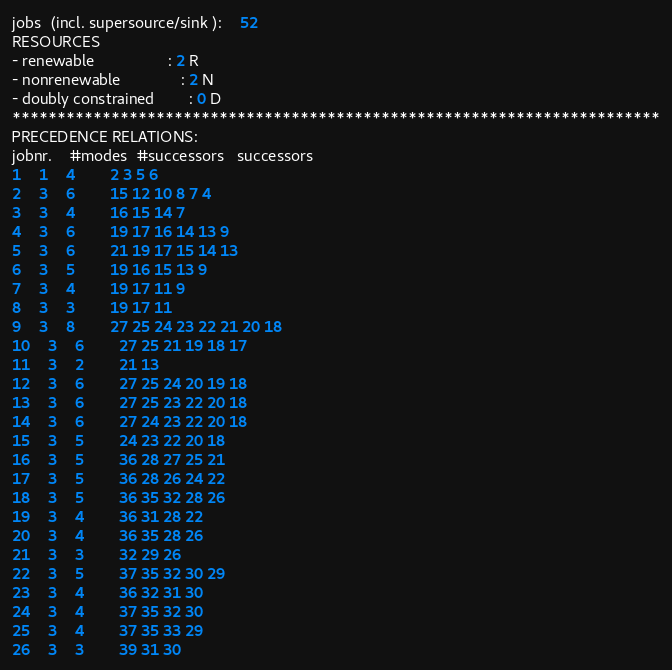Convert code to text. <code><loc_0><loc_0><loc_500><loc_500><_ObjectiveC_>jobs  (incl. supersource/sink ):	52
RESOURCES
- renewable                 : 2 R
- nonrenewable              : 2 N
- doubly constrained        : 0 D
************************************************************************
PRECEDENCE RELATIONS:
jobnr.    #modes  #successors   successors
1	1	4		2 3 5 6 
2	3	6		15 12 10 8 7 4 
3	3	4		16 15 14 7 
4	3	6		19 17 16 14 13 9 
5	3	6		21 19 17 15 14 13 
6	3	5		19 16 15 13 9 
7	3	4		19 17 11 9 
8	3	3		19 17 11 
9	3	8		27 25 24 23 22 21 20 18 
10	3	6		27 25 21 19 18 17 
11	3	2		21 13 
12	3	6		27 25 24 20 19 18 
13	3	6		27 25 23 22 20 18 
14	3	6		27 24 23 22 20 18 
15	3	5		24 23 22 20 18 
16	3	5		36 28 27 25 21 
17	3	5		36 28 26 24 22 
18	3	5		36 35 32 28 26 
19	3	4		36 31 28 22 
20	3	4		36 35 28 26 
21	3	3		32 29 26 
22	3	5		37 35 32 30 29 
23	3	4		36 32 31 30 
24	3	4		37 35 32 30 
25	3	4		37 35 33 29 
26	3	3		39 31 30 </code> 